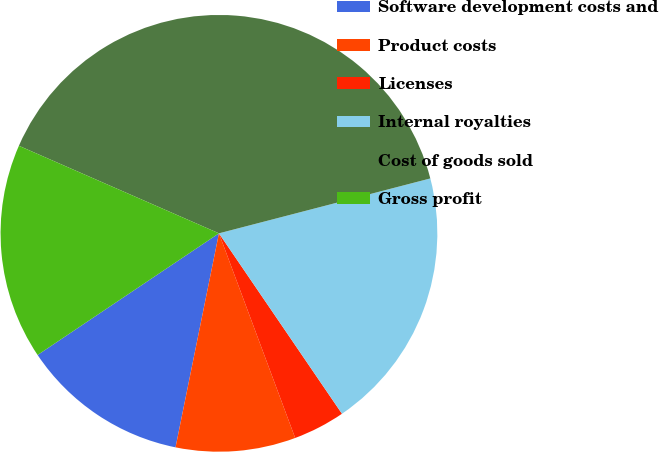Convert chart to OTSL. <chart><loc_0><loc_0><loc_500><loc_500><pie_chart><fcel>Software development costs and<fcel>Product costs<fcel>Licenses<fcel>Internal royalties<fcel>Cost of goods sold<fcel>Gross profit<nl><fcel>12.41%<fcel>8.86%<fcel>3.85%<fcel>19.52%<fcel>39.39%<fcel>15.97%<nl></chart> 